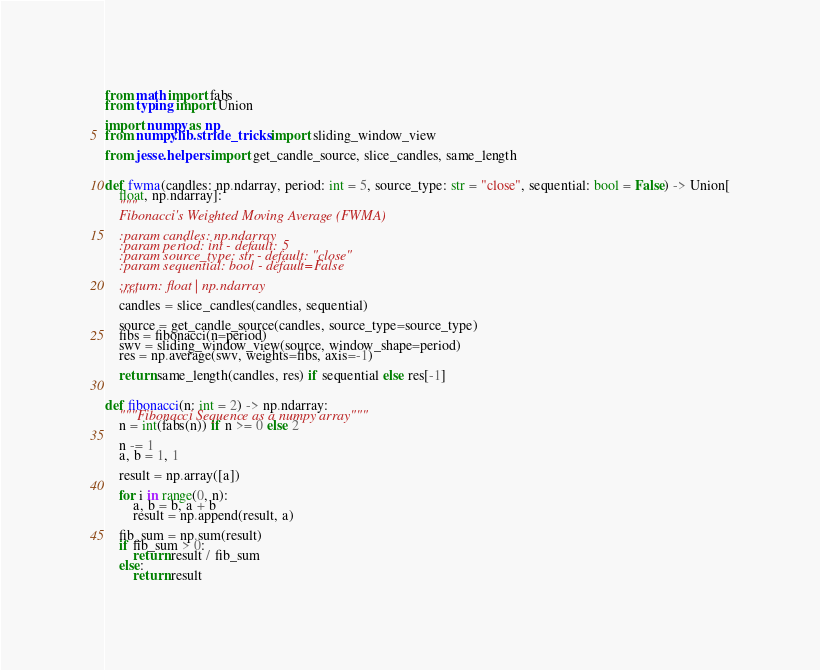Convert code to text. <code><loc_0><loc_0><loc_500><loc_500><_Python_>from math import fabs
from typing import Union

import numpy as np
from numpy.lib.stride_tricks import sliding_window_view

from jesse.helpers import get_candle_source, slice_candles, same_length


def fwma(candles: np.ndarray, period: int = 5, source_type: str = "close", sequential: bool = False) -> Union[
    float, np.ndarray]:
    """
    Fibonacci's Weighted Moving Average (FWMA)

    :param candles: np.ndarray
    :param period: int - default: 5
    :param source_type: str - default: "close"
    :param sequential: bool - default=False

    :return: float | np.ndarray
    """
    candles = slice_candles(candles, sequential)

    source = get_candle_source(candles, source_type=source_type)
    fibs = fibonacci(n=period)
    swv = sliding_window_view(source, window_shape=period)
    res = np.average(swv, weights=fibs, axis=-1)

    return same_length(candles, res) if sequential else res[-1]


def fibonacci(n: int = 2) -> np.ndarray:
    """Fibonacci Sequence as a numpy array"""
    n = int(fabs(n)) if n >= 0 else 2

    n -= 1
    a, b = 1, 1

    result = np.array([a])

    for i in range(0, n):
        a, b = b, a + b
        result = np.append(result, a)

    fib_sum = np.sum(result)
    if fib_sum > 0:
        return result / fib_sum
    else:
        return result
</code> 